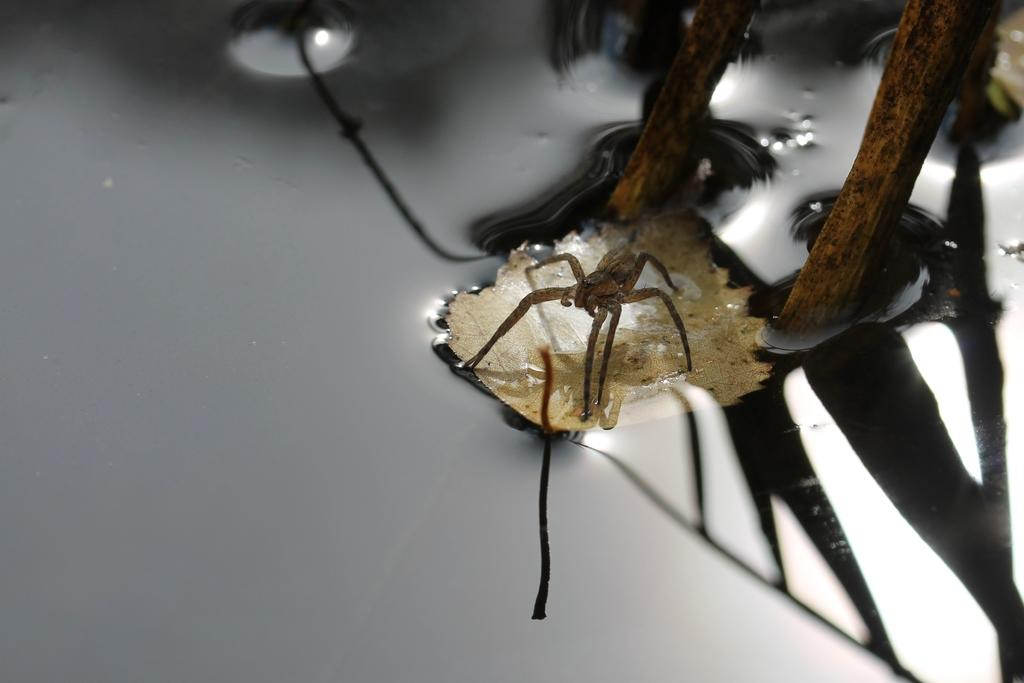What is the main subject of the picture? The main subject of the picture is an insect. Where is the insect located in the picture? The insect is in the middle of the picture. What is the insect resting on? The insect is on a leaf. What is the leaf doing in the picture? The leaf is floating on the water. How many rings are visible on the insect's body in the image? There are no rings visible on the insect's body in the image. What type of connection can be seen between the insect and the leaf in the image? There is no visible connection between the insect and the leaf in the image; the insect is simply resting on the leaf. 